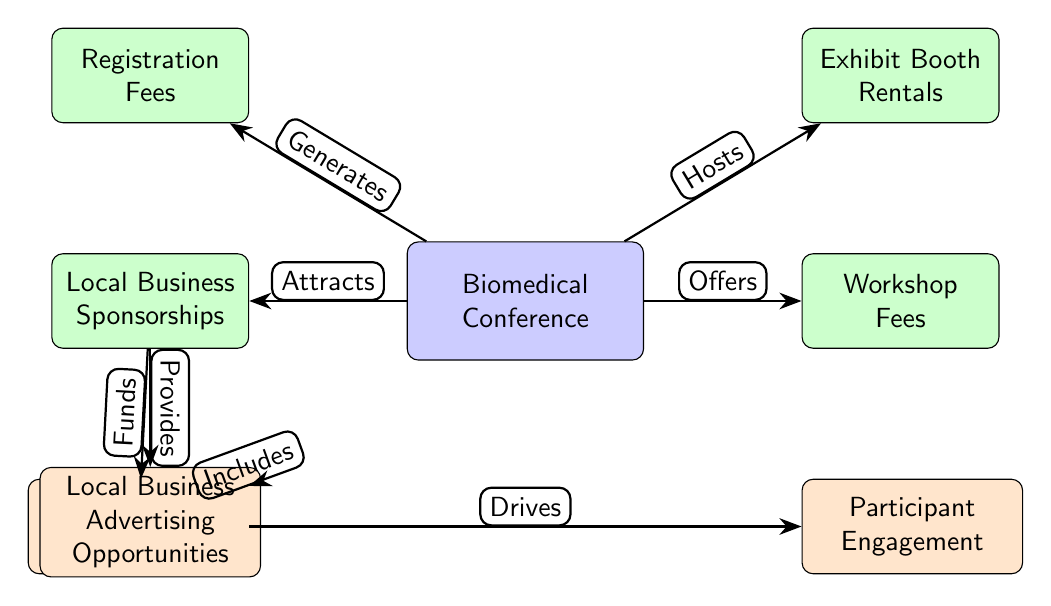What are the primary revenue sources depicted in the diagram? The diagram shows three primary revenue sources for the Biomedical Conference: Registration Fees, Local Business Sponsorships, and Exhibit Booth Rentals. These are represented as secondary nodes directly connected to the main node (Biomedical Conference).
Answer: Registration Fees, Local Business Sponsorships, Exhibit Booth Rentals How many total nodes are present in the diagram? There are a total of eight nodes in the diagram. The main node represents the Biomedical Conference and is connected to six other nodes, including three secondary nodes and three tertiary nodes.
Answer: Eight What role do local businesses play in the conference's structure? Local businesses contribute by providing sponsorships, which are indicated by the arrow labeled "Attracts" pointing to the node representing Local Business Sponsorships. They also create advertising opportunities as shown in the node beneath it, connected by the edge labeled "Provides."
Answer: Sponsorships and advertising opportunities What drives participant engagement according to the diagram? Participant engagement is driven by Advertising and Promotions, which is a tertiary node. This node is reached through a direct connection from Local Business Advertising Opportunities, as indicated by the flow of the edges.
Answer: Advertising and Promotions How does the Local Business Sponsorships node relate to the Advertising and Promotions node? The Local Business Sponsorships node provides funding that connects directly to the Advertising and Promotions node, showing that sponsorships contribute financially to the promotions. This relationship is illustrated by the edge "Funds" leading from Local Business Sponsorships to Advertising and Promotions.
Answer: Provides funding What is the connection between Workshop Fees and the Biomedical Conference? Workshop Fees are one of the revenue sources that the Biomedical Conference offers as a service to participants, indicated by the direct edge labeled "Offers" from the Biomedical Conference node to the Workshop Fees node.
Answer: One of the revenue sources 